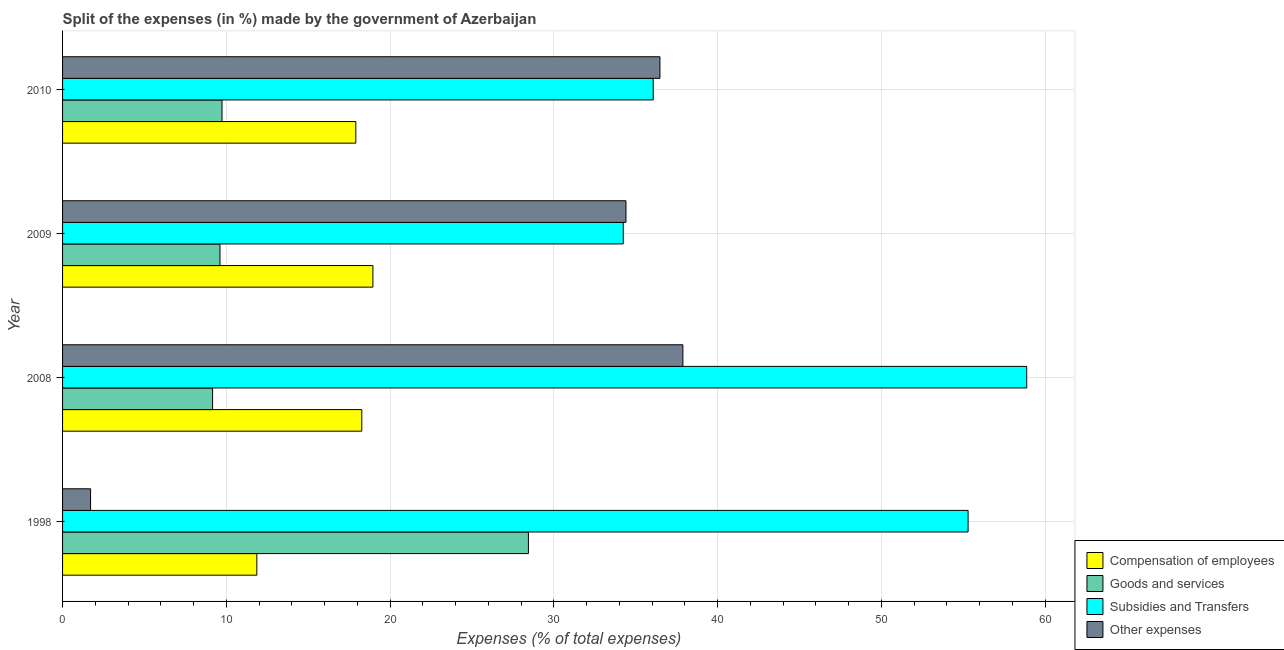How many different coloured bars are there?
Provide a succinct answer. 4. How many groups of bars are there?
Your answer should be compact. 4. Are the number of bars per tick equal to the number of legend labels?
Ensure brevity in your answer.  Yes. Are the number of bars on each tick of the Y-axis equal?
Make the answer very short. Yes. How many bars are there on the 2nd tick from the top?
Make the answer very short. 4. How many bars are there on the 2nd tick from the bottom?
Keep it short and to the point. 4. What is the percentage of amount spent on compensation of employees in 2008?
Keep it short and to the point. 18.27. Across all years, what is the maximum percentage of amount spent on compensation of employees?
Make the answer very short. 18.95. Across all years, what is the minimum percentage of amount spent on goods and services?
Your answer should be very brief. 9.16. What is the total percentage of amount spent on goods and services in the graph?
Offer a very short reply. 56.96. What is the difference between the percentage of amount spent on other expenses in 2008 and that in 2009?
Keep it short and to the point. 3.48. What is the difference between the percentage of amount spent on other expenses in 2010 and the percentage of amount spent on goods and services in 2009?
Make the answer very short. 26.87. What is the average percentage of amount spent on compensation of employees per year?
Keep it short and to the point. 16.75. In the year 2010, what is the difference between the percentage of amount spent on compensation of employees and percentage of amount spent on goods and services?
Your response must be concise. 8.17. What is the ratio of the percentage of amount spent on other expenses in 1998 to that in 2010?
Provide a short and direct response. 0.05. Is the difference between the percentage of amount spent on other expenses in 2008 and 2010 greater than the difference between the percentage of amount spent on subsidies in 2008 and 2010?
Your response must be concise. No. What is the difference between the highest and the second highest percentage of amount spent on compensation of employees?
Make the answer very short. 0.68. What is the difference between the highest and the lowest percentage of amount spent on subsidies?
Your answer should be very brief. 24.64. In how many years, is the percentage of amount spent on compensation of employees greater than the average percentage of amount spent on compensation of employees taken over all years?
Provide a short and direct response. 3. Is it the case that in every year, the sum of the percentage of amount spent on compensation of employees and percentage of amount spent on subsidies is greater than the sum of percentage of amount spent on goods and services and percentage of amount spent on other expenses?
Ensure brevity in your answer.  No. What does the 2nd bar from the top in 2010 represents?
Give a very brief answer. Subsidies and Transfers. What does the 4th bar from the bottom in 2009 represents?
Give a very brief answer. Other expenses. Are all the bars in the graph horizontal?
Your answer should be compact. Yes. How many years are there in the graph?
Your response must be concise. 4. What is the difference between two consecutive major ticks on the X-axis?
Make the answer very short. 10. Where does the legend appear in the graph?
Offer a terse response. Bottom right. What is the title of the graph?
Ensure brevity in your answer.  Split of the expenses (in %) made by the government of Azerbaijan. What is the label or title of the X-axis?
Give a very brief answer. Expenses (% of total expenses). What is the Expenses (% of total expenses) of Compensation of employees in 1998?
Give a very brief answer. 11.86. What is the Expenses (% of total expenses) of Goods and services in 1998?
Your answer should be very brief. 28.45. What is the Expenses (% of total expenses) in Subsidies and Transfers in 1998?
Ensure brevity in your answer.  55.3. What is the Expenses (% of total expenses) of Other expenses in 1998?
Your response must be concise. 1.71. What is the Expenses (% of total expenses) in Compensation of employees in 2008?
Keep it short and to the point. 18.27. What is the Expenses (% of total expenses) of Goods and services in 2008?
Give a very brief answer. 9.16. What is the Expenses (% of total expenses) of Subsidies and Transfers in 2008?
Your answer should be compact. 58.88. What is the Expenses (% of total expenses) in Other expenses in 2008?
Your answer should be very brief. 37.88. What is the Expenses (% of total expenses) of Compensation of employees in 2009?
Your response must be concise. 18.95. What is the Expenses (% of total expenses) in Goods and services in 2009?
Provide a short and direct response. 9.61. What is the Expenses (% of total expenses) of Subsidies and Transfers in 2009?
Offer a terse response. 34.24. What is the Expenses (% of total expenses) of Other expenses in 2009?
Ensure brevity in your answer.  34.41. What is the Expenses (% of total expenses) in Compensation of employees in 2010?
Your answer should be compact. 17.91. What is the Expenses (% of total expenses) of Goods and services in 2010?
Your answer should be compact. 9.74. What is the Expenses (% of total expenses) in Subsidies and Transfers in 2010?
Provide a short and direct response. 36.07. What is the Expenses (% of total expenses) in Other expenses in 2010?
Offer a very short reply. 36.48. Across all years, what is the maximum Expenses (% of total expenses) in Compensation of employees?
Your answer should be very brief. 18.95. Across all years, what is the maximum Expenses (% of total expenses) in Goods and services?
Keep it short and to the point. 28.45. Across all years, what is the maximum Expenses (% of total expenses) of Subsidies and Transfers?
Your answer should be compact. 58.88. Across all years, what is the maximum Expenses (% of total expenses) in Other expenses?
Your answer should be compact. 37.88. Across all years, what is the minimum Expenses (% of total expenses) in Compensation of employees?
Make the answer very short. 11.86. Across all years, what is the minimum Expenses (% of total expenses) in Goods and services?
Give a very brief answer. 9.16. Across all years, what is the minimum Expenses (% of total expenses) of Subsidies and Transfers?
Your response must be concise. 34.24. Across all years, what is the minimum Expenses (% of total expenses) in Other expenses?
Keep it short and to the point. 1.71. What is the total Expenses (% of total expenses) of Compensation of employees in the graph?
Your response must be concise. 67. What is the total Expenses (% of total expenses) of Goods and services in the graph?
Provide a short and direct response. 56.96. What is the total Expenses (% of total expenses) in Subsidies and Transfers in the graph?
Your answer should be very brief. 184.49. What is the total Expenses (% of total expenses) in Other expenses in the graph?
Offer a terse response. 110.48. What is the difference between the Expenses (% of total expenses) in Compensation of employees in 1998 and that in 2008?
Make the answer very short. -6.41. What is the difference between the Expenses (% of total expenses) of Goods and services in 1998 and that in 2008?
Provide a short and direct response. 19.29. What is the difference between the Expenses (% of total expenses) in Subsidies and Transfers in 1998 and that in 2008?
Your answer should be very brief. -3.58. What is the difference between the Expenses (% of total expenses) in Other expenses in 1998 and that in 2008?
Your answer should be very brief. -36.17. What is the difference between the Expenses (% of total expenses) in Compensation of employees in 1998 and that in 2009?
Offer a terse response. -7.09. What is the difference between the Expenses (% of total expenses) in Goods and services in 1998 and that in 2009?
Provide a succinct answer. 18.84. What is the difference between the Expenses (% of total expenses) of Subsidies and Transfers in 1998 and that in 2009?
Offer a very short reply. 21.06. What is the difference between the Expenses (% of total expenses) in Other expenses in 1998 and that in 2009?
Provide a succinct answer. -32.7. What is the difference between the Expenses (% of total expenses) in Compensation of employees in 1998 and that in 2010?
Your answer should be very brief. -6.04. What is the difference between the Expenses (% of total expenses) in Goods and services in 1998 and that in 2010?
Give a very brief answer. 18.71. What is the difference between the Expenses (% of total expenses) of Subsidies and Transfers in 1998 and that in 2010?
Provide a succinct answer. 19.23. What is the difference between the Expenses (% of total expenses) of Other expenses in 1998 and that in 2010?
Your answer should be compact. -34.77. What is the difference between the Expenses (% of total expenses) in Compensation of employees in 2008 and that in 2009?
Your answer should be compact. -0.68. What is the difference between the Expenses (% of total expenses) in Goods and services in 2008 and that in 2009?
Offer a terse response. -0.45. What is the difference between the Expenses (% of total expenses) of Subsidies and Transfers in 2008 and that in 2009?
Make the answer very short. 24.64. What is the difference between the Expenses (% of total expenses) of Other expenses in 2008 and that in 2009?
Give a very brief answer. 3.48. What is the difference between the Expenses (% of total expenses) in Compensation of employees in 2008 and that in 2010?
Your answer should be very brief. 0.37. What is the difference between the Expenses (% of total expenses) in Goods and services in 2008 and that in 2010?
Ensure brevity in your answer.  -0.58. What is the difference between the Expenses (% of total expenses) in Subsidies and Transfers in 2008 and that in 2010?
Keep it short and to the point. 22.81. What is the difference between the Expenses (% of total expenses) of Other expenses in 2008 and that in 2010?
Make the answer very short. 1.4. What is the difference between the Expenses (% of total expenses) in Compensation of employees in 2009 and that in 2010?
Your answer should be very brief. 1.04. What is the difference between the Expenses (% of total expenses) of Goods and services in 2009 and that in 2010?
Give a very brief answer. -0.13. What is the difference between the Expenses (% of total expenses) of Subsidies and Transfers in 2009 and that in 2010?
Keep it short and to the point. -1.83. What is the difference between the Expenses (% of total expenses) in Other expenses in 2009 and that in 2010?
Make the answer very short. -2.07. What is the difference between the Expenses (% of total expenses) in Compensation of employees in 1998 and the Expenses (% of total expenses) in Goods and services in 2008?
Make the answer very short. 2.7. What is the difference between the Expenses (% of total expenses) in Compensation of employees in 1998 and the Expenses (% of total expenses) in Subsidies and Transfers in 2008?
Make the answer very short. -47.02. What is the difference between the Expenses (% of total expenses) in Compensation of employees in 1998 and the Expenses (% of total expenses) in Other expenses in 2008?
Provide a short and direct response. -26.02. What is the difference between the Expenses (% of total expenses) of Goods and services in 1998 and the Expenses (% of total expenses) of Subsidies and Transfers in 2008?
Offer a terse response. -30.43. What is the difference between the Expenses (% of total expenses) in Goods and services in 1998 and the Expenses (% of total expenses) in Other expenses in 2008?
Ensure brevity in your answer.  -9.43. What is the difference between the Expenses (% of total expenses) in Subsidies and Transfers in 1998 and the Expenses (% of total expenses) in Other expenses in 2008?
Offer a terse response. 17.42. What is the difference between the Expenses (% of total expenses) of Compensation of employees in 1998 and the Expenses (% of total expenses) of Goods and services in 2009?
Your response must be concise. 2.25. What is the difference between the Expenses (% of total expenses) of Compensation of employees in 1998 and the Expenses (% of total expenses) of Subsidies and Transfers in 2009?
Offer a very short reply. -22.38. What is the difference between the Expenses (% of total expenses) of Compensation of employees in 1998 and the Expenses (% of total expenses) of Other expenses in 2009?
Offer a very short reply. -22.54. What is the difference between the Expenses (% of total expenses) of Goods and services in 1998 and the Expenses (% of total expenses) of Subsidies and Transfers in 2009?
Ensure brevity in your answer.  -5.79. What is the difference between the Expenses (% of total expenses) of Goods and services in 1998 and the Expenses (% of total expenses) of Other expenses in 2009?
Offer a terse response. -5.96. What is the difference between the Expenses (% of total expenses) of Subsidies and Transfers in 1998 and the Expenses (% of total expenses) of Other expenses in 2009?
Offer a very short reply. 20.89. What is the difference between the Expenses (% of total expenses) in Compensation of employees in 1998 and the Expenses (% of total expenses) in Goods and services in 2010?
Make the answer very short. 2.13. What is the difference between the Expenses (% of total expenses) of Compensation of employees in 1998 and the Expenses (% of total expenses) of Subsidies and Transfers in 2010?
Provide a short and direct response. -24.21. What is the difference between the Expenses (% of total expenses) in Compensation of employees in 1998 and the Expenses (% of total expenses) in Other expenses in 2010?
Your answer should be very brief. -24.62. What is the difference between the Expenses (% of total expenses) in Goods and services in 1998 and the Expenses (% of total expenses) in Subsidies and Transfers in 2010?
Your answer should be compact. -7.62. What is the difference between the Expenses (% of total expenses) of Goods and services in 1998 and the Expenses (% of total expenses) of Other expenses in 2010?
Make the answer very short. -8.03. What is the difference between the Expenses (% of total expenses) of Subsidies and Transfers in 1998 and the Expenses (% of total expenses) of Other expenses in 2010?
Your answer should be compact. 18.82. What is the difference between the Expenses (% of total expenses) of Compensation of employees in 2008 and the Expenses (% of total expenses) of Goods and services in 2009?
Keep it short and to the point. 8.66. What is the difference between the Expenses (% of total expenses) of Compensation of employees in 2008 and the Expenses (% of total expenses) of Subsidies and Transfers in 2009?
Give a very brief answer. -15.97. What is the difference between the Expenses (% of total expenses) of Compensation of employees in 2008 and the Expenses (% of total expenses) of Other expenses in 2009?
Your answer should be very brief. -16.13. What is the difference between the Expenses (% of total expenses) in Goods and services in 2008 and the Expenses (% of total expenses) in Subsidies and Transfers in 2009?
Your answer should be very brief. -25.08. What is the difference between the Expenses (% of total expenses) of Goods and services in 2008 and the Expenses (% of total expenses) of Other expenses in 2009?
Your answer should be very brief. -25.25. What is the difference between the Expenses (% of total expenses) of Subsidies and Transfers in 2008 and the Expenses (% of total expenses) of Other expenses in 2009?
Provide a short and direct response. 24.47. What is the difference between the Expenses (% of total expenses) of Compensation of employees in 2008 and the Expenses (% of total expenses) of Goods and services in 2010?
Your answer should be very brief. 8.54. What is the difference between the Expenses (% of total expenses) of Compensation of employees in 2008 and the Expenses (% of total expenses) of Subsidies and Transfers in 2010?
Your answer should be compact. -17.8. What is the difference between the Expenses (% of total expenses) in Compensation of employees in 2008 and the Expenses (% of total expenses) in Other expenses in 2010?
Keep it short and to the point. -18.21. What is the difference between the Expenses (% of total expenses) in Goods and services in 2008 and the Expenses (% of total expenses) in Subsidies and Transfers in 2010?
Make the answer very short. -26.91. What is the difference between the Expenses (% of total expenses) of Goods and services in 2008 and the Expenses (% of total expenses) of Other expenses in 2010?
Ensure brevity in your answer.  -27.32. What is the difference between the Expenses (% of total expenses) in Subsidies and Transfers in 2008 and the Expenses (% of total expenses) in Other expenses in 2010?
Provide a short and direct response. 22.4. What is the difference between the Expenses (% of total expenses) in Compensation of employees in 2009 and the Expenses (% of total expenses) in Goods and services in 2010?
Provide a succinct answer. 9.21. What is the difference between the Expenses (% of total expenses) in Compensation of employees in 2009 and the Expenses (% of total expenses) in Subsidies and Transfers in 2010?
Provide a short and direct response. -17.12. What is the difference between the Expenses (% of total expenses) in Compensation of employees in 2009 and the Expenses (% of total expenses) in Other expenses in 2010?
Give a very brief answer. -17.53. What is the difference between the Expenses (% of total expenses) of Goods and services in 2009 and the Expenses (% of total expenses) of Subsidies and Transfers in 2010?
Offer a terse response. -26.46. What is the difference between the Expenses (% of total expenses) in Goods and services in 2009 and the Expenses (% of total expenses) in Other expenses in 2010?
Provide a succinct answer. -26.87. What is the difference between the Expenses (% of total expenses) of Subsidies and Transfers in 2009 and the Expenses (% of total expenses) of Other expenses in 2010?
Offer a terse response. -2.24. What is the average Expenses (% of total expenses) in Compensation of employees per year?
Give a very brief answer. 16.75. What is the average Expenses (% of total expenses) in Goods and services per year?
Offer a very short reply. 14.24. What is the average Expenses (% of total expenses) of Subsidies and Transfers per year?
Your answer should be very brief. 46.12. What is the average Expenses (% of total expenses) of Other expenses per year?
Provide a short and direct response. 27.62. In the year 1998, what is the difference between the Expenses (% of total expenses) of Compensation of employees and Expenses (% of total expenses) of Goods and services?
Your response must be concise. -16.58. In the year 1998, what is the difference between the Expenses (% of total expenses) of Compensation of employees and Expenses (% of total expenses) of Subsidies and Transfers?
Make the answer very short. -43.44. In the year 1998, what is the difference between the Expenses (% of total expenses) of Compensation of employees and Expenses (% of total expenses) of Other expenses?
Your answer should be compact. 10.15. In the year 1998, what is the difference between the Expenses (% of total expenses) in Goods and services and Expenses (% of total expenses) in Subsidies and Transfers?
Offer a very short reply. -26.85. In the year 1998, what is the difference between the Expenses (% of total expenses) of Goods and services and Expenses (% of total expenses) of Other expenses?
Keep it short and to the point. 26.74. In the year 1998, what is the difference between the Expenses (% of total expenses) in Subsidies and Transfers and Expenses (% of total expenses) in Other expenses?
Make the answer very short. 53.59. In the year 2008, what is the difference between the Expenses (% of total expenses) in Compensation of employees and Expenses (% of total expenses) in Goods and services?
Ensure brevity in your answer.  9.11. In the year 2008, what is the difference between the Expenses (% of total expenses) in Compensation of employees and Expenses (% of total expenses) in Subsidies and Transfers?
Give a very brief answer. -40.61. In the year 2008, what is the difference between the Expenses (% of total expenses) of Compensation of employees and Expenses (% of total expenses) of Other expenses?
Offer a very short reply. -19.61. In the year 2008, what is the difference between the Expenses (% of total expenses) of Goods and services and Expenses (% of total expenses) of Subsidies and Transfers?
Your response must be concise. -49.72. In the year 2008, what is the difference between the Expenses (% of total expenses) of Goods and services and Expenses (% of total expenses) of Other expenses?
Provide a short and direct response. -28.72. In the year 2008, what is the difference between the Expenses (% of total expenses) in Subsidies and Transfers and Expenses (% of total expenses) in Other expenses?
Your response must be concise. 21. In the year 2009, what is the difference between the Expenses (% of total expenses) in Compensation of employees and Expenses (% of total expenses) in Goods and services?
Offer a very short reply. 9.34. In the year 2009, what is the difference between the Expenses (% of total expenses) in Compensation of employees and Expenses (% of total expenses) in Subsidies and Transfers?
Provide a short and direct response. -15.29. In the year 2009, what is the difference between the Expenses (% of total expenses) of Compensation of employees and Expenses (% of total expenses) of Other expenses?
Give a very brief answer. -15.45. In the year 2009, what is the difference between the Expenses (% of total expenses) in Goods and services and Expenses (% of total expenses) in Subsidies and Transfers?
Ensure brevity in your answer.  -24.63. In the year 2009, what is the difference between the Expenses (% of total expenses) of Goods and services and Expenses (% of total expenses) of Other expenses?
Give a very brief answer. -24.79. In the year 2009, what is the difference between the Expenses (% of total expenses) of Subsidies and Transfers and Expenses (% of total expenses) of Other expenses?
Give a very brief answer. -0.16. In the year 2010, what is the difference between the Expenses (% of total expenses) in Compensation of employees and Expenses (% of total expenses) in Goods and services?
Offer a very short reply. 8.17. In the year 2010, what is the difference between the Expenses (% of total expenses) of Compensation of employees and Expenses (% of total expenses) of Subsidies and Transfers?
Offer a very short reply. -18.16. In the year 2010, what is the difference between the Expenses (% of total expenses) in Compensation of employees and Expenses (% of total expenses) in Other expenses?
Keep it short and to the point. -18.57. In the year 2010, what is the difference between the Expenses (% of total expenses) in Goods and services and Expenses (% of total expenses) in Subsidies and Transfers?
Make the answer very short. -26.33. In the year 2010, what is the difference between the Expenses (% of total expenses) in Goods and services and Expenses (% of total expenses) in Other expenses?
Give a very brief answer. -26.74. In the year 2010, what is the difference between the Expenses (% of total expenses) of Subsidies and Transfers and Expenses (% of total expenses) of Other expenses?
Provide a succinct answer. -0.41. What is the ratio of the Expenses (% of total expenses) in Compensation of employees in 1998 to that in 2008?
Ensure brevity in your answer.  0.65. What is the ratio of the Expenses (% of total expenses) of Goods and services in 1998 to that in 2008?
Offer a terse response. 3.11. What is the ratio of the Expenses (% of total expenses) in Subsidies and Transfers in 1998 to that in 2008?
Offer a terse response. 0.94. What is the ratio of the Expenses (% of total expenses) in Other expenses in 1998 to that in 2008?
Your answer should be very brief. 0.05. What is the ratio of the Expenses (% of total expenses) of Compensation of employees in 1998 to that in 2009?
Your response must be concise. 0.63. What is the ratio of the Expenses (% of total expenses) of Goods and services in 1998 to that in 2009?
Your answer should be compact. 2.96. What is the ratio of the Expenses (% of total expenses) in Subsidies and Transfers in 1998 to that in 2009?
Keep it short and to the point. 1.61. What is the ratio of the Expenses (% of total expenses) of Other expenses in 1998 to that in 2009?
Your answer should be very brief. 0.05. What is the ratio of the Expenses (% of total expenses) of Compensation of employees in 1998 to that in 2010?
Provide a short and direct response. 0.66. What is the ratio of the Expenses (% of total expenses) of Goods and services in 1998 to that in 2010?
Your answer should be very brief. 2.92. What is the ratio of the Expenses (% of total expenses) in Subsidies and Transfers in 1998 to that in 2010?
Give a very brief answer. 1.53. What is the ratio of the Expenses (% of total expenses) of Other expenses in 1998 to that in 2010?
Offer a very short reply. 0.05. What is the ratio of the Expenses (% of total expenses) of Compensation of employees in 2008 to that in 2009?
Ensure brevity in your answer.  0.96. What is the ratio of the Expenses (% of total expenses) of Goods and services in 2008 to that in 2009?
Offer a terse response. 0.95. What is the ratio of the Expenses (% of total expenses) in Subsidies and Transfers in 2008 to that in 2009?
Provide a succinct answer. 1.72. What is the ratio of the Expenses (% of total expenses) in Other expenses in 2008 to that in 2009?
Give a very brief answer. 1.1. What is the ratio of the Expenses (% of total expenses) in Compensation of employees in 2008 to that in 2010?
Offer a terse response. 1.02. What is the ratio of the Expenses (% of total expenses) in Goods and services in 2008 to that in 2010?
Your response must be concise. 0.94. What is the ratio of the Expenses (% of total expenses) in Subsidies and Transfers in 2008 to that in 2010?
Keep it short and to the point. 1.63. What is the ratio of the Expenses (% of total expenses) in Other expenses in 2008 to that in 2010?
Offer a very short reply. 1.04. What is the ratio of the Expenses (% of total expenses) of Compensation of employees in 2009 to that in 2010?
Give a very brief answer. 1.06. What is the ratio of the Expenses (% of total expenses) of Goods and services in 2009 to that in 2010?
Ensure brevity in your answer.  0.99. What is the ratio of the Expenses (% of total expenses) in Subsidies and Transfers in 2009 to that in 2010?
Make the answer very short. 0.95. What is the ratio of the Expenses (% of total expenses) of Other expenses in 2009 to that in 2010?
Offer a very short reply. 0.94. What is the difference between the highest and the second highest Expenses (% of total expenses) of Compensation of employees?
Provide a short and direct response. 0.68. What is the difference between the highest and the second highest Expenses (% of total expenses) of Goods and services?
Keep it short and to the point. 18.71. What is the difference between the highest and the second highest Expenses (% of total expenses) of Subsidies and Transfers?
Provide a short and direct response. 3.58. What is the difference between the highest and the second highest Expenses (% of total expenses) in Other expenses?
Give a very brief answer. 1.4. What is the difference between the highest and the lowest Expenses (% of total expenses) in Compensation of employees?
Offer a terse response. 7.09. What is the difference between the highest and the lowest Expenses (% of total expenses) in Goods and services?
Your response must be concise. 19.29. What is the difference between the highest and the lowest Expenses (% of total expenses) in Subsidies and Transfers?
Give a very brief answer. 24.64. What is the difference between the highest and the lowest Expenses (% of total expenses) in Other expenses?
Offer a very short reply. 36.17. 